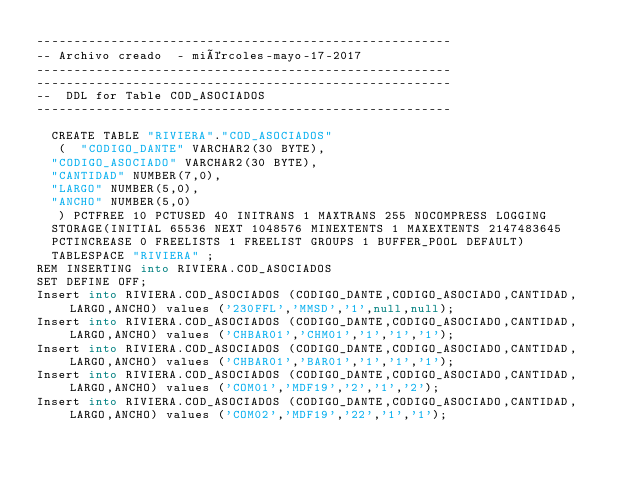<code> <loc_0><loc_0><loc_500><loc_500><_SQL_>--------------------------------------------------------
-- Archivo creado  - miércoles-mayo-17-2017   
--------------------------------------------------------
--------------------------------------------------------
--  DDL for Table COD_ASOCIADOS
--------------------------------------------------------

  CREATE TABLE "RIVIERA"."COD_ASOCIADOS" 
   (	"CODIGO_DANTE" VARCHAR2(30 BYTE), 
	"CODIGO_ASOCIADO" VARCHAR2(30 BYTE), 
	"CANTIDAD" NUMBER(7,0), 
	"LARGO" NUMBER(5,0), 
	"ANCHO" NUMBER(5,0)
   ) PCTFREE 10 PCTUSED 40 INITRANS 1 MAXTRANS 255 NOCOMPRESS LOGGING
  STORAGE(INITIAL 65536 NEXT 1048576 MINEXTENTS 1 MAXEXTENTS 2147483645
  PCTINCREASE 0 FREELISTS 1 FREELIST GROUPS 1 BUFFER_POOL DEFAULT)
  TABLESPACE "RIVIERA" ;
REM INSERTING into RIVIERA.COD_ASOCIADOS
SET DEFINE OFF;
Insert into RIVIERA.COD_ASOCIADOS (CODIGO_DANTE,CODIGO_ASOCIADO,CANTIDAD,LARGO,ANCHO) values ('230FFL','MMSD','1',null,null);
Insert into RIVIERA.COD_ASOCIADOS (CODIGO_DANTE,CODIGO_ASOCIADO,CANTIDAD,LARGO,ANCHO) values ('CHBAR01','CHM01','1','1','1');
Insert into RIVIERA.COD_ASOCIADOS (CODIGO_DANTE,CODIGO_ASOCIADO,CANTIDAD,LARGO,ANCHO) values ('CHBAR01','BAR01','1','1','1');
Insert into RIVIERA.COD_ASOCIADOS (CODIGO_DANTE,CODIGO_ASOCIADO,CANTIDAD,LARGO,ANCHO) values ('COM01','MDF19','2','1','2');
Insert into RIVIERA.COD_ASOCIADOS (CODIGO_DANTE,CODIGO_ASOCIADO,CANTIDAD,LARGO,ANCHO) values ('COM02','MDF19','22','1','1');
</code> 